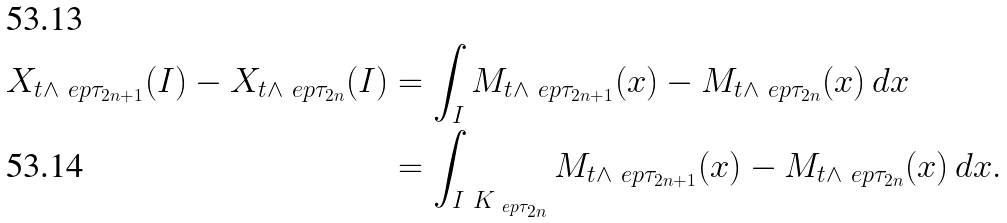<formula> <loc_0><loc_0><loc_500><loc_500>X _ { t \wedge \ e p { \tau _ { 2 n + 1 } } } ( I ) - X _ { t \wedge \ e p { \tau _ { 2 n } } } ( I ) & = \int _ { I } M _ { t \wedge \ e p { \tau _ { 2 n + 1 } } } ( x ) - M _ { t \wedge \ e p { \tau _ { 2 n } } } ( x ) \, d x \\ & = \int _ { I \ K _ { \ e p { \tau _ { 2 n } } } } M _ { t \wedge \ e p { \tau _ { 2 n + 1 } } } ( x ) - M _ { t \wedge \ e p { \tau _ { 2 n } } } ( x ) \, d x .</formula> 